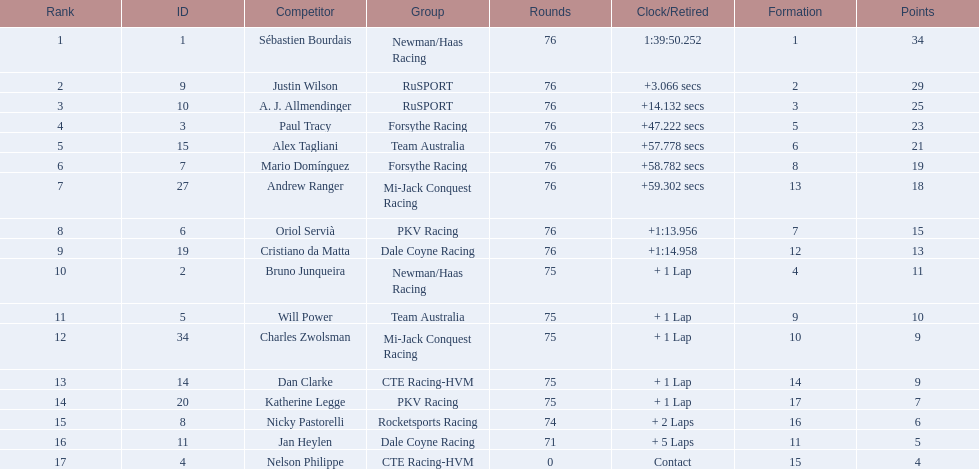How many points did charles zwolsman acquire? 9. Who else got 9 points? Dan Clarke. 